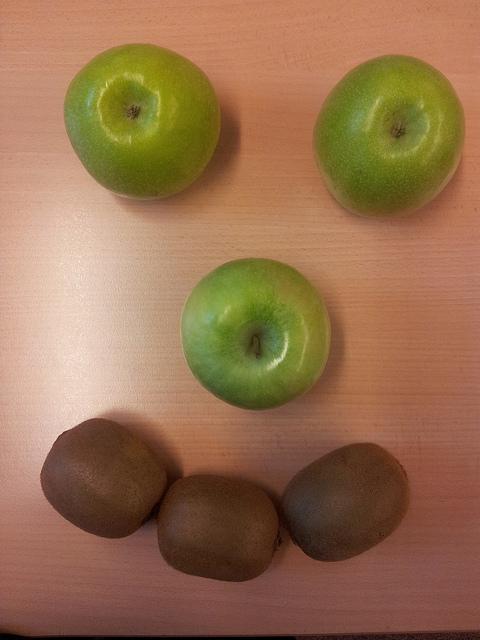How many apples are there?
Give a very brief answer. 3. How many kiwis are in this photo?
Give a very brief answer. 3. 